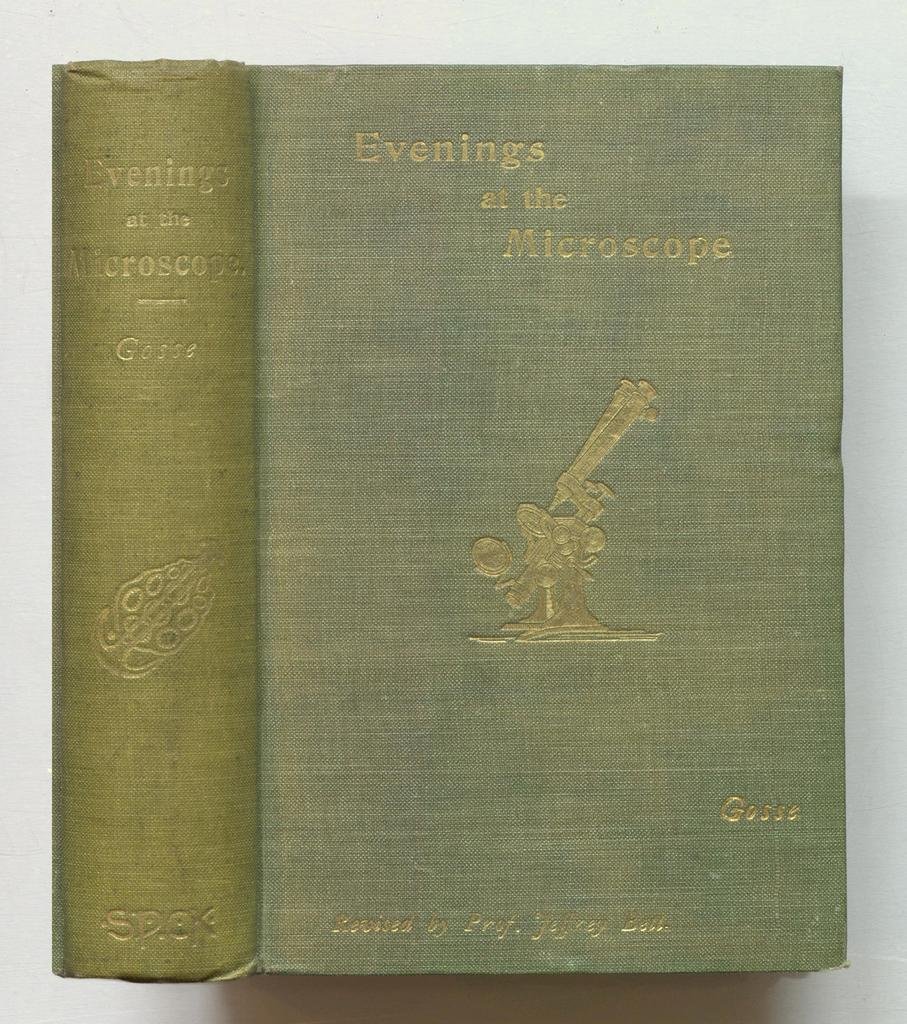<image>
Provide a brief description of the given image. An old green book called "Evenings at the Microscope" 